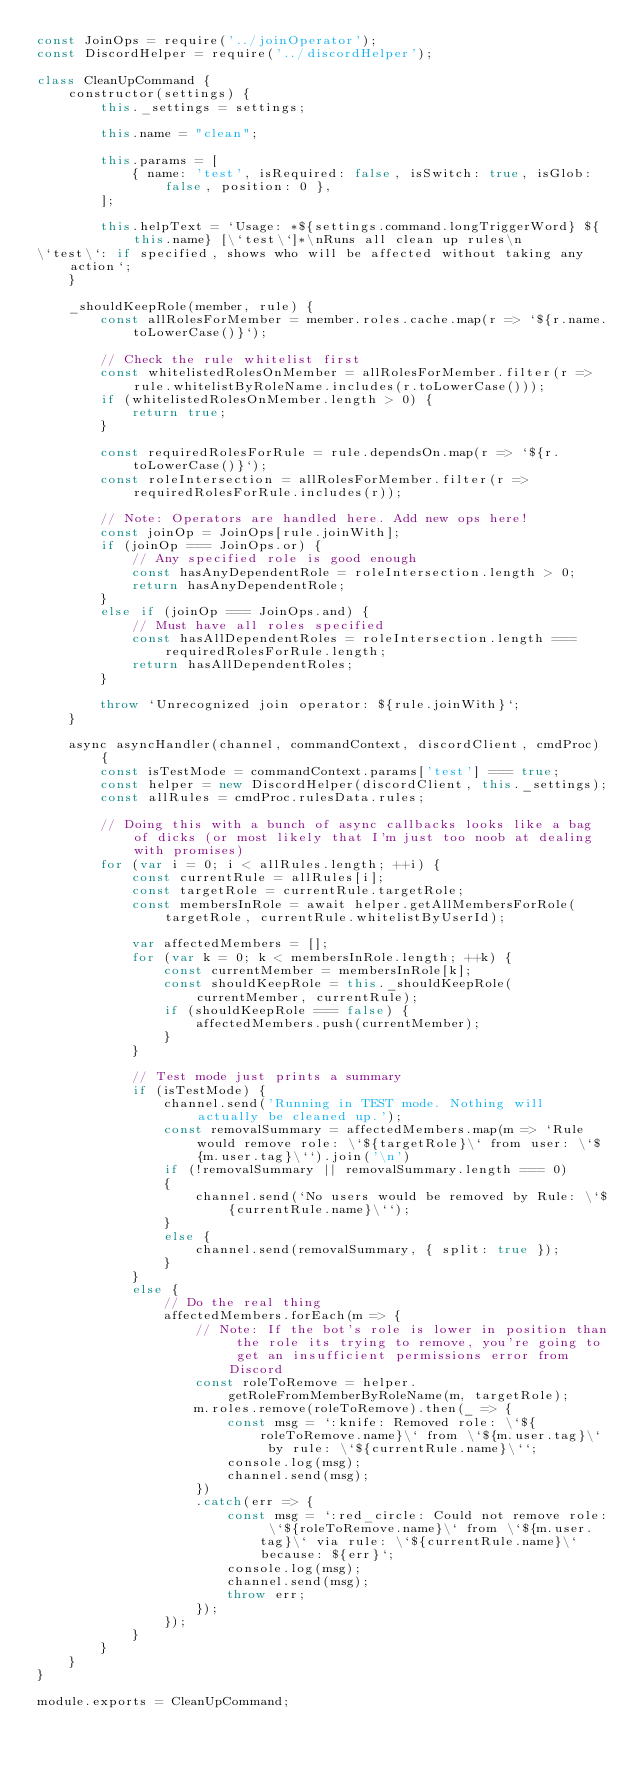Convert code to text. <code><loc_0><loc_0><loc_500><loc_500><_JavaScript_>const JoinOps = require('../joinOperator');
const DiscordHelper = require('../discordHelper');

class CleanUpCommand {
    constructor(settings) {
        this._settings = settings;

        this.name = "clean";

        this.params = [
            { name: 'test', isRequired: false, isSwitch: true, isGlob: false, position: 0 },
        ];

        this.helpText = `Usage: *${settings.command.longTriggerWord} ${this.name} [\`test\`]*\nRuns all clean up rules\n
\`test\`: if specified, shows who will be affected without taking any action`;
    }

    _shouldKeepRole(member, rule) {
        const allRolesForMember = member.roles.cache.map(r => `${r.name.toLowerCase()}`);

        // Check the rule whitelist first
        const whitelistedRolesOnMember = allRolesForMember.filter(r => rule.whitelistByRoleName.includes(r.toLowerCase()));
        if (whitelistedRolesOnMember.length > 0) {
            return true;
        }

        const requiredRolesForRule = rule.dependsOn.map(r => `${r.toLowerCase()}`);
        const roleIntersection = allRolesForMember.filter(r => requiredRolesForRule.includes(r));

        // Note: Operators are handled here. Add new ops here!
        const joinOp = JoinOps[rule.joinWith];
        if (joinOp === JoinOps.or) {
            // Any specified role is good enough
            const hasAnyDependentRole = roleIntersection.length > 0;
            return hasAnyDependentRole;
        }
        else if (joinOp === JoinOps.and) {
            // Must have all roles specified
            const hasAllDependentRoles = roleIntersection.length === requiredRolesForRule.length;
            return hasAllDependentRoles;
        }

        throw `Unrecognized join operator: ${rule.joinWith}`;
    }

    async asyncHandler(channel, commandContext, discordClient, cmdProc) {
        const isTestMode = commandContext.params['test'] === true;
        const helper = new DiscordHelper(discordClient, this._settings);
        const allRules = cmdProc.rulesData.rules;

        // Doing this with a bunch of async callbacks looks like a bag of dicks (or most likely that I'm just too noob at dealing with promises)
        for (var i = 0; i < allRules.length; ++i) {
            const currentRule = allRules[i];
            const targetRole = currentRule.targetRole;
            const membersInRole = await helper.getAllMembersForRole(targetRole, currentRule.whitelistByUserId);

            var affectedMembers = [];
            for (var k = 0; k < membersInRole.length; ++k) {
                const currentMember = membersInRole[k];
                const shouldKeepRole = this._shouldKeepRole(currentMember, currentRule);
                if (shouldKeepRole === false) {
                    affectedMembers.push(currentMember);
                }
            }

            // Test mode just prints a summary
            if (isTestMode) {
                channel.send('Running in TEST mode. Nothing will actually be cleaned up.');
                const removalSummary = affectedMembers.map(m => `Rule would remove role: \`${targetRole}\` from user: \`${m.user.tag}\``).join('\n')
                if (!removalSummary || removalSummary.length === 0)
                {
                    channel.send(`No users would be removed by Rule: \`${currentRule.name}\``);
                }
                else {
                    channel.send(removalSummary, { split: true });
                }
            }
            else {
                // Do the real thing
                affectedMembers.forEach(m => {
                    // Note: If the bot's role is lower in position than the role its trying to remove, you're going to get an insufficient permissions error from Discord
                    const roleToRemove = helper.getRoleFromMemberByRoleName(m, targetRole);
                    m.roles.remove(roleToRemove).then(_ => {
                        const msg = `:knife: Removed role: \`${roleToRemove.name}\` from \`${m.user.tag}\` by rule: \`${currentRule.name}\``;
                        console.log(msg);
                        channel.send(msg);
                    })
                    .catch(err => {
                        const msg = `:red_circle: Could not remove role: \`${roleToRemove.name}\` from \`${m.user.tag}\` via rule: \`${currentRule.name}\` because: ${err}`;
                        console.log(msg);
                        channel.send(msg);
                        throw err;
                    });
                });
            }
        }
    }
}

module.exports = CleanUpCommand;
</code> 